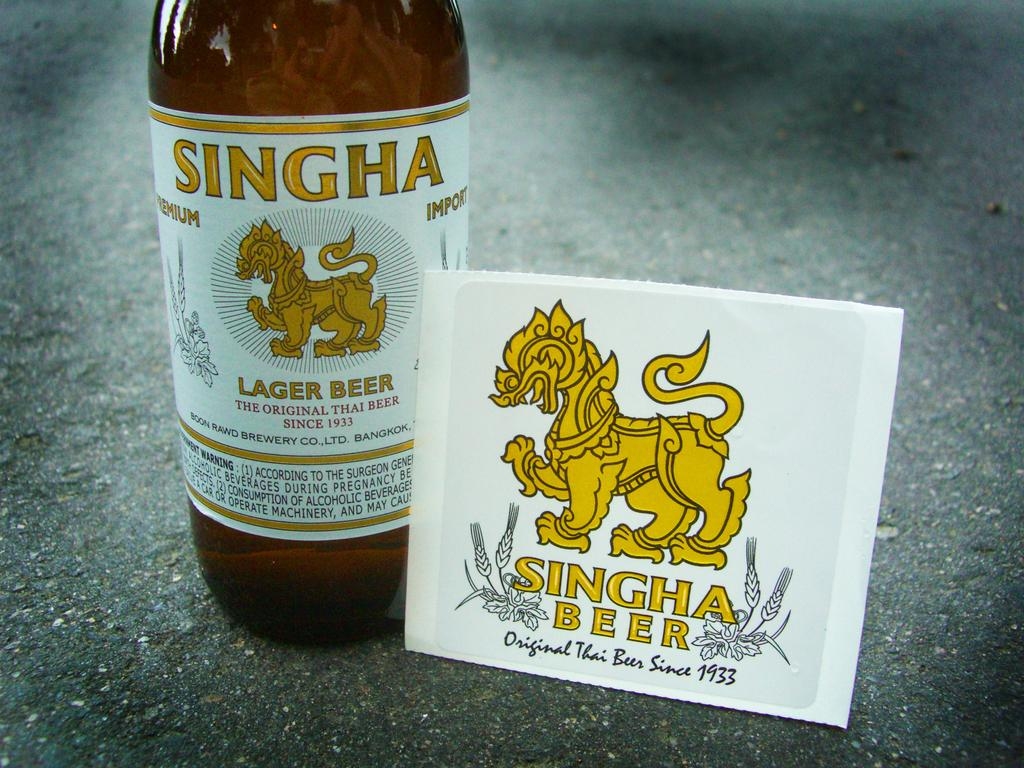Provide a one-sentence caption for the provided image. A bottle of beer and a coaster both with a yellow mythical figure and the name SINGHA beer on them. 